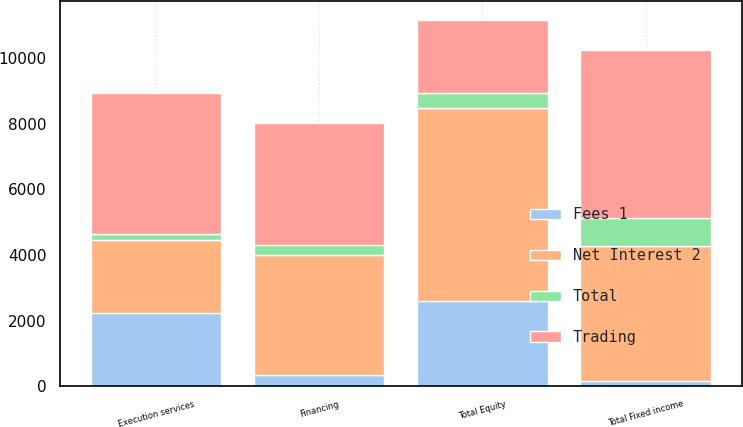Convert chart to OTSL. <chart><loc_0><loc_0><loc_500><loc_500><stacked_bar_chart><ecel><fcel>Financing<fcel>Execution services<fcel>Total Equity<fcel>Total Fixed income<nl><fcel>Net Interest 2<fcel>3668<fcel>2231<fcel>5899<fcel>4115<nl><fcel>Fees 1<fcel>347<fcel>2241<fcel>2588<fcel>162<nl><fcel>Total<fcel>283<fcel>167<fcel>450<fcel>840<nl><fcel>Trading<fcel>3732<fcel>4305<fcel>2241<fcel>5117<nl></chart> 